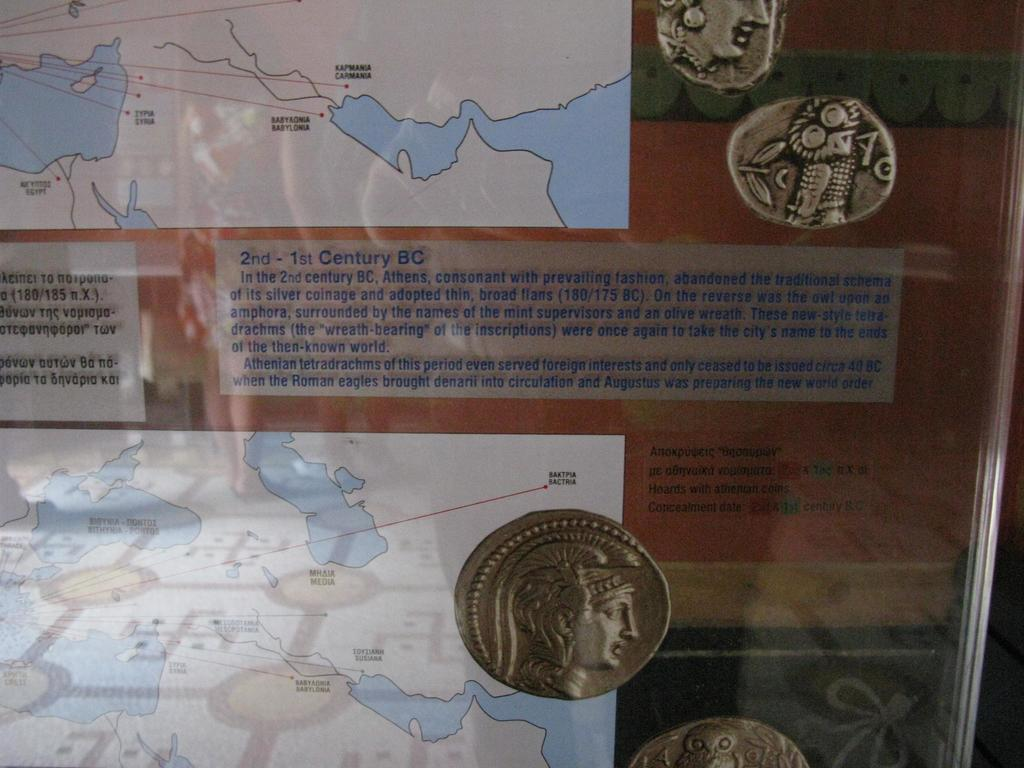Provide a one-sentence caption for the provided image. A FEW COINS THAT WERE USED IN 2ND-1ST BC. 